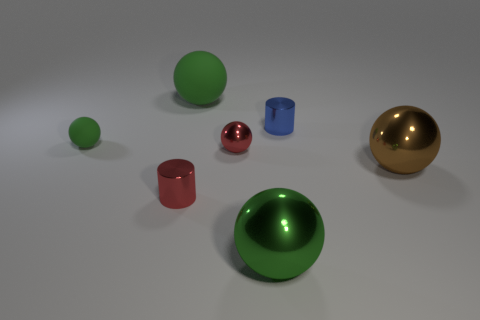There is a big matte thing that is the same color as the tiny matte ball; what is its shape?
Your answer should be compact. Sphere. Are there more brown metallic balls to the left of the small green thing than large green matte things?
Your answer should be very brief. No. There is a large matte sphere; what number of large green things are in front of it?
Provide a short and direct response. 1. Are there any other brown metallic objects of the same size as the brown thing?
Your answer should be compact. No. The other thing that is the same shape as the small blue thing is what color?
Ensure brevity in your answer.  Red. Are there the same number of tiny red matte balls and metal objects?
Your answer should be compact. No. There is a green sphere that is in front of the red metallic cylinder; does it have the same size as the red shiny object behind the brown metallic ball?
Give a very brief answer. No. Is there a tiny gray shiny object that has the same shape as the large brown metallic object?
Ensure brevity in your answer.  No. Are there an equal number of small blue metal objects that are in front of the small green thing and red cylinders?
Ensure brevity in your answer.  No. Do the red cylinder and the rubber object behind the small green object have the same size?
Your answer should be very brief. No. 